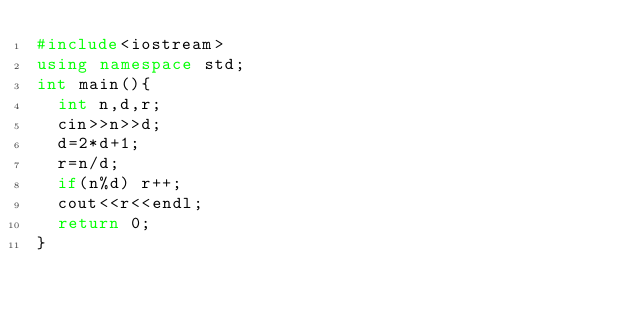Convert code to text. <code><loc_0><loc_0><loc_500><loc_500><_C++_>#include<iostream>
using namespace std;
int main(){
  int n,d,r;
  cin>>n>>d;
  d=2*d+1;
  r=n/d;
  if(n%d) r++;
  cout<<r<<endl;
  return 0;
}</code> 